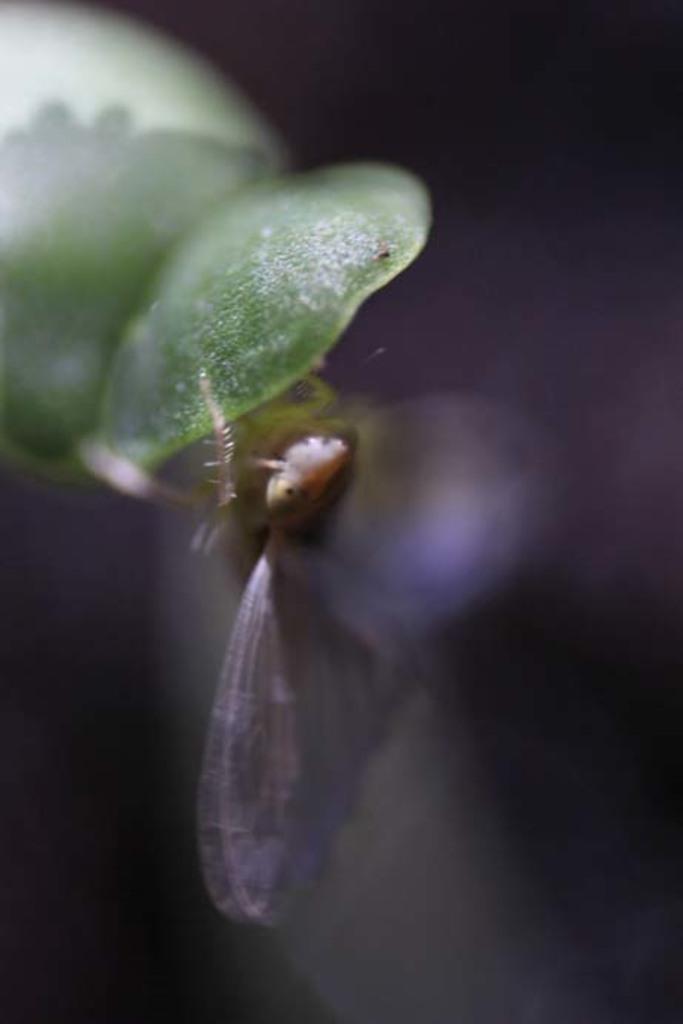Please provide a concise description of this image. This image is blurred, where we can see an insect on the green color object and the background of the image is dark. 